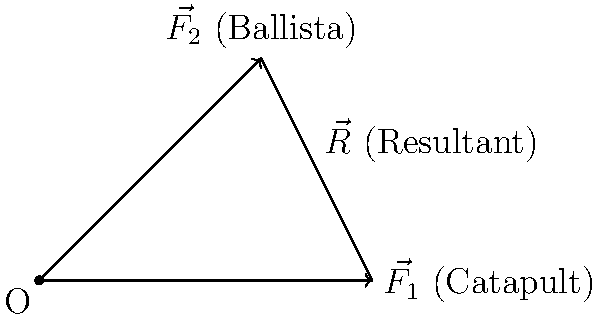In the siege of a medieval castle, two ancient weapons are employed simultaneously: a catapult exerting a force $\vec{F_1}$ of 300 N east, and a ballista applying a force $\vec{F_2}$ of 400 N at an angle of 45° north of east. Calculate the magnitude of the resultant force $\vec{R}$ on the castle wall. To find the resultant force, we'll use the parallelogram method of vector addition. Let's break this down step-by-step:

1) First, let's identify the components of each force:
   
   $\vec{F_1}$: 300 N east (x-direction)
   $\vec{F_2}$: 400 N at 45° north of east

2) We need to break $\vec{F_2}$ into its x and y components:
   
   $F_{2x} = 400 \cos 45° = 400 \cdot \frac{\sqrt{2}}{2} \approx 282.8$ N
   $F_{2y} = 400 \sin 45° = 400 \cdot \frac{\sqrt{2}}{2} \approx 282.8$ N

3) Now, we can sum the forces in each direction:
   
   $R_x = F_{1x} + F_{2x} = 300 + 282.8 = 582.8$ N
   $R_y = F_{1y} + F_{2y} = 0 + 282.8 = 282.8$ N

4) The resultant force $\vec{R}$ is the vector sum of these components. To find its magnitude, we use the Pythagorean theorem:

   $|\vec{R}| = \sqrt{R_x^2 + R_y^2} = \sqrt{582.8^2 + 282.8^2} \approx 648.2$ N

Therefore, the magnitude of the resultant force on the castle wall is approximately 648.2 N.
Answer: 648.2 N 